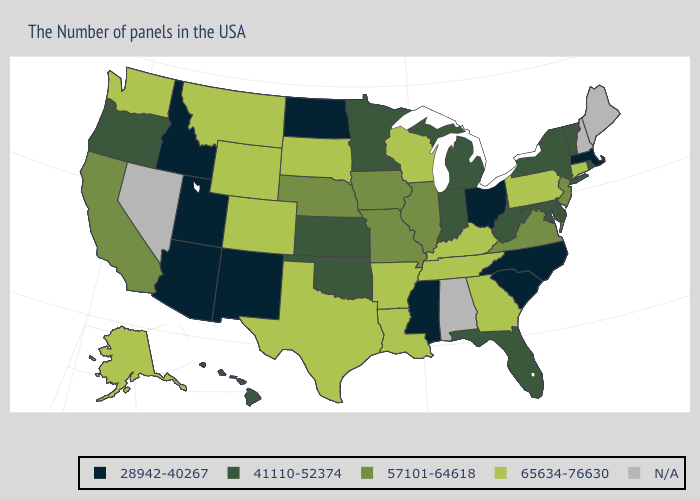What is the highest value in the USA?
Short answer required. 65634-76630. What is the value of Georgia?
Quick response, please. 65634-76630. What is the lowest value in the West?
Answer briefly. 28942-40267. Which states have the lowest value in the USA?
Concise answer only. Massachusetts, North Carolina, South Carolina, Ohio, Mississippi, North Dakota, New Mexico, Utah, Arizona, Idaho. What is the highest value in states that border Washington?
Concise answer only. 41110-52374. Among the states that border New Jersey , does New York have the lowest value?
Write a very short answer. Yes. Does the first symbol in the legend represent the smallest category?
Short answer required. Yes. Name the states that have a value in the range 28942-40267?
Give a very brief answer. Massachusetts, North Carolina, South Carolina, Ohio, Mississippi, North Dakota, New Mexico, Utah, Arizona, Idaho. Is the legend a continuous bar?
Write a very short answer. No. Which states have the lowest value in the MidWest?
Be succinct. Ohio, North Dakota. What is the lowest value in the USA?
Write a very short answer. 28942-40267. Among the states that border North Carolina , does Virginia have the lowest value?
Concise answer only. No. Does the map have missing data?
Answer briefly. Yes. What is the value of Maryland?
Short answer required. 41110-52374. Does Louisiana have the highest value in the South?
Write a very short answer. Yes. 